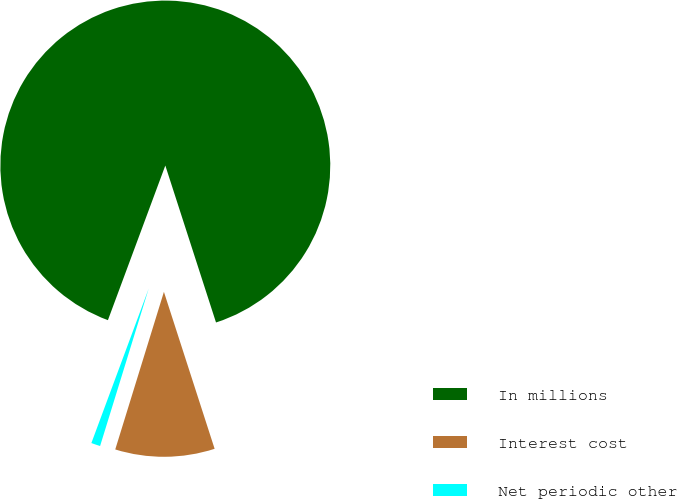<chart> <loc_0><loc_0><loc_500><loc_500><pie_chart><fcel>In millions<fcel>Interest cost<fcel>Net periodic other<nl><fcel>89.37%<fcel>9.74%<fcel>0.89%<nl></chart> 